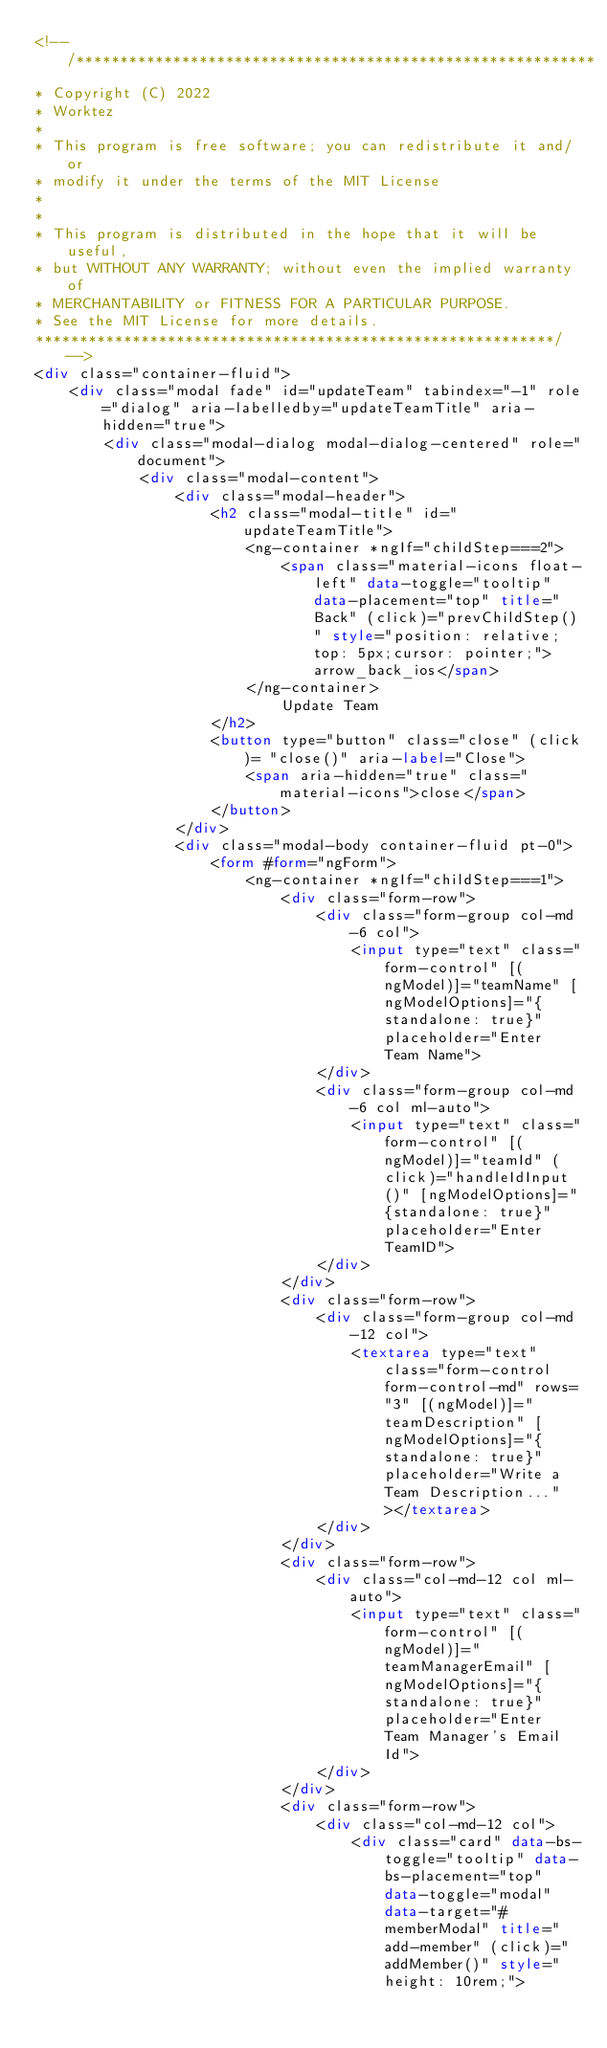<code> <loc_0><loc_0><loc_500><loc_500><_HTML_><!-- /*********************************************************** 
* Copyright (C) 2022 
* Worktez 
* 
* This program is free software; you can redistribute it and/or 
* modify it under the terms of the MIT License 
* 
* 
* This program is distributed in the hope that it will be useful, 
* but WITHOUT ANY WARRANTY; without even the implied warranty of 
* MERCHANTABILITY or FITNESS FOR A PARTICULAR PURPOSE. 
* See the MIT License for more details. 
***********************************************************/ -->
<div class="container-fluid">
    <div class="modal fade" id="updateTeam" tabindex="-1" role="dialog" aria-labelledby="updateTeamTitle" aria-hidden="true">
        <div class="modal-dialog modal-dialog-centered" role="document">
            <div class="modal-content">
                <div class="modal-header">
                    <h2 class="modal-title" id="updateTeamTitle">
                        <ng-container *ngIf="childStep===2">
                            <span class="material-icons float-left" data-toggle="tooltip" data-placement="top" title="Back" (click)="prevChildStep()" style="position: relative;top: 5px;cursor: pointer;">arrow_back_ios</span>
                        </ng-container>
                            Update Team
                    </h2>
                    <button type="button" class="close" (click)= "close()" aria-label="Close">
                        <span aria-hidden="true" class="material-icons">close</span>
                    </button>
                </div>
                <div class="modal-body container-fluid pt-0">
                    <form #form="ngForm">
                        <ng-container *ngIf="childStep===1">
                            <div class="form-row">
                                <div class="form-group col-md-6 col">
                                    <input type="text" class="form-control" [(ngModel)]="teamName" [ngModelOptions]="{standalone: true}" placeholder="Enter Team Name">
                                </div>
                                <div class="form-group col-md-6 col ml-auto">
                                    <input type="text" class="form-control" [(ngModel)]="teamId" (click)="handleIdInput()" [ngModelOptions]="{standalone: true}" placeholder="Enter TeamID">
                                </div>
                            </div>
                            <div class="form-row">
                                <div class="form-group col-md-12 col">
                                    <textarea type="text" class="form-control form-control-md" rows="3" [(ngModel)]="teamDescription" [ngModelOptions]="{standalone: true}" placeholder="Write a Team Description..."></textarea>
                                </div>
                            </div>
                            <div class="form-row">
                                <div class="col-md-12 col ml-auto">
                                    <input type="text" class="form-control" [(ngModel)]="teamManagerEmail" [ngModelOptions]="{standalone: true}" placeholder="Enter Team Manager's Email Id">
                                </div>
                            </div>
                            <div class="form-row">
                                <div class="col-md-12 col">
                                    <div class="card" data-bs-toggle="tooltip" data-bs-placement="top" data-toggle="modal" data-target="#memberModal" title="add-member" (click)="addMember()" style="height: 10rem;"></code> 